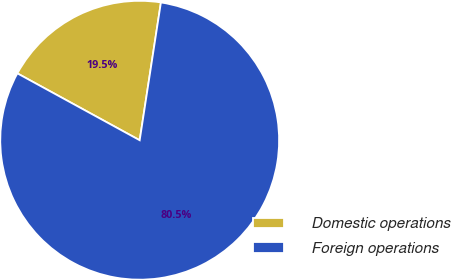Convert chart. <chart><loc_0><loc_0><loc_500><loc_500><pie_chart><fcel>Domestic operations<fcel>Foreign operations<nl><fcel>19.47%<fcel>80.53%<nl></chart> 